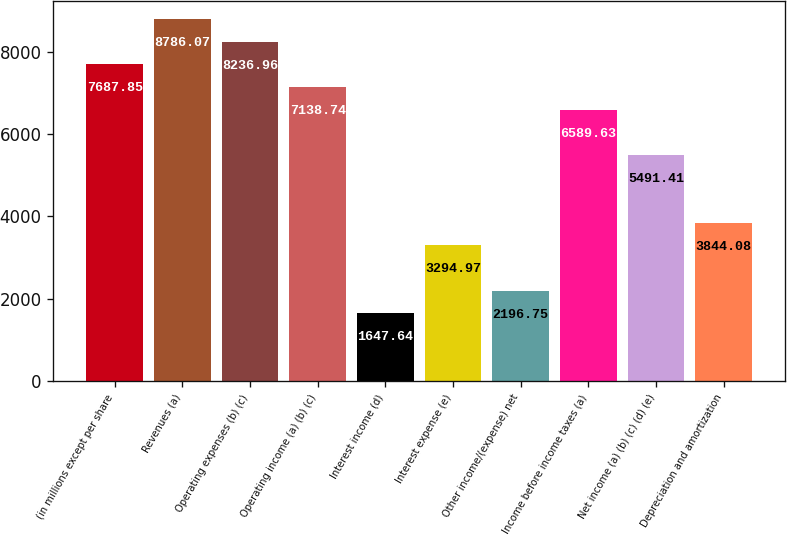<chart> <loc_0><loc_0><loc_500><loc_500><bar_chart><fcel>(in millions except per share<fcel>Revenues (a)<fcel>Operating expenses (b) (c)<fcel>Operating income (a) (b) (c)<fcel>Interest income (d)<fcel>Interest expense (e)<fcel>Other income/(expense) net<fcel>Income before income taxes (a)<fcel>Net income (a) (b) (c) (d) (e)<fcel>Depreciation and amortization<nl><fcel>7687.85<fcel>8786.07<fcel>8236.96<fcel>7138.74<fcel>1647.64<fcel>3294.97<fcel>2196.75<fcel>6589.63<fcel>5491.41<fcel>3844.08<nl></chart> 